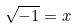<formula> <loc_0><loc_0><loc_500><loc_500>\sqrt { - 1 } = x</formula> 